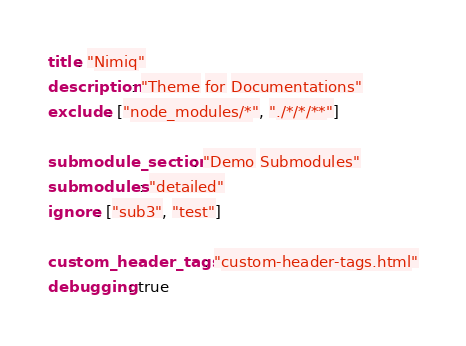Convert code to text. <code><loc_0><loc_0><loc_500><loc_500><_YAML_>title: "Nimiq"
description: "Theme for Documentations"
exclude: ["node_modules/*", "./*/*/**"]

submodule_section: "Demo Submodules"
submodules: "detailed"
ignore: ["sub3", "test"]

custom_header_tags: "custom-header-tags.html"
debugging: true
</code> 